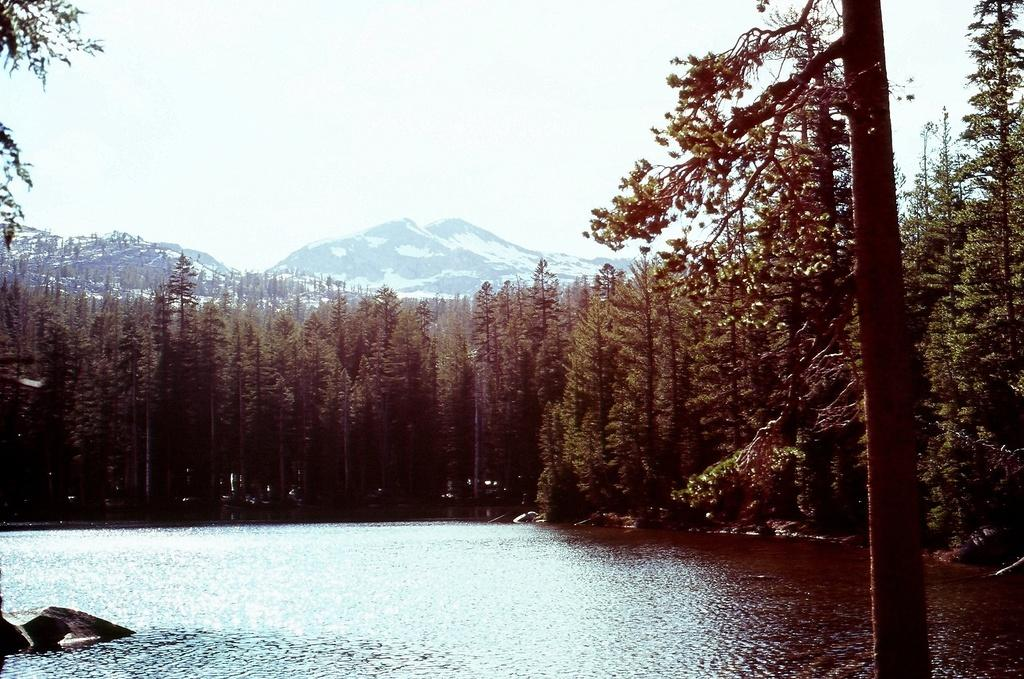What is the main subject of the image? The main subject of the image is a lake with water flowing. What type of vegetation can be seen in the image? There are trees with branches and leaves in the image. What geographical feature is visible in the background? In the background, mountains with snow are visible. What type of sack is being used to attack the trees in the image? There is no sack or attack present in the image; it depicts a peaceful scene with a lake, trees, and mountains. 